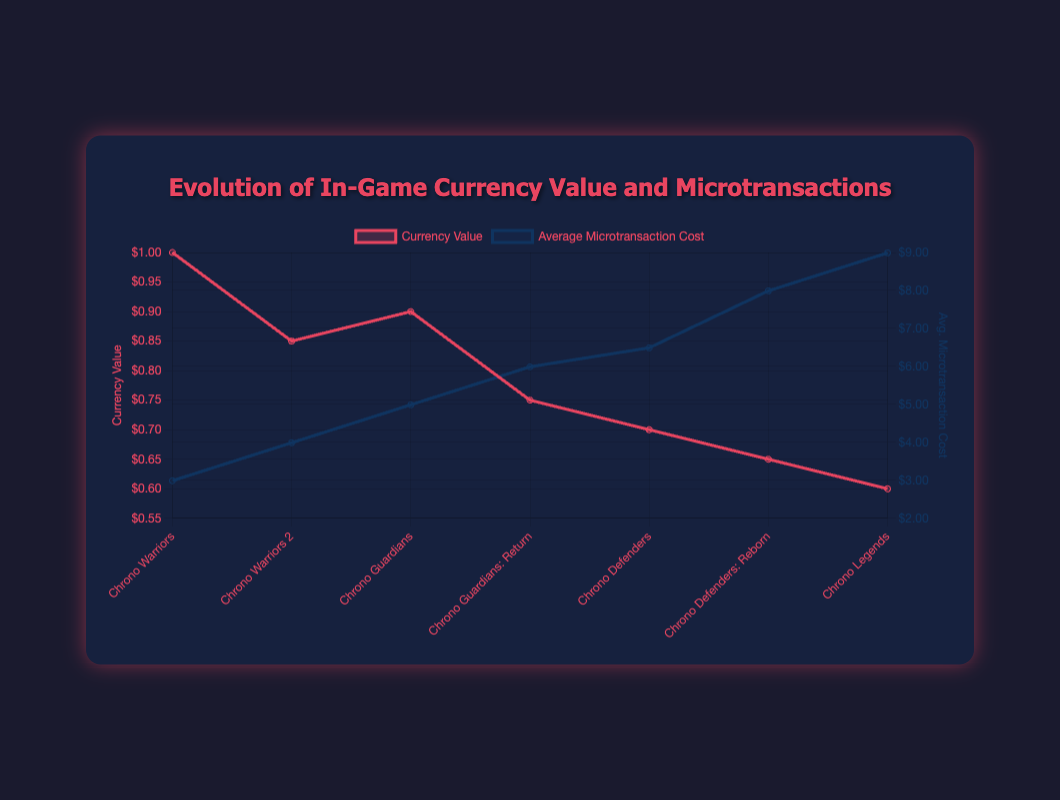What is the trend of the currency value from "Chrono Warriors" to "Chrono Legends"? The currency value decreases consistently from $1.00 in "Chrono Warriors" to $0.60 in "Chrono Legends". Each subsequent game has a lower currency value than its predecessor, indicating a downward trend.
Answer: The currency value decreases Which game has the highest average microtransaction cost? By examining the line representing average microtransaction costs, "Chrono Legends" has the highest value at $8.99. The corresponding peak at this point visually confirms this.
Answer: Chrono Legends How much has the average microtransaction cost increased from "Chrono Warriors" to "Chrono Legends"? The average microtransaction cost in "Chrono Warriors" is $2.99, while in "Chrono Legends" it is $8.99. The increase is $8.99 - $2.99 = $6.00.
Answer: $6.00 In which year did the currency value first drop below $0.80? The currency value dropped below $0.80 for the first time in 2016 with "Chrono Guardians: Return", where the value was $0.75.
Answer: 2016 Which game has a higher currency value, "Chrono Warriors 2" or "Chrono Guardians"? Comparing the currency values of "Chrono Warriors 2" ($0.85) and "Chrono Guardians" ($0.90) shows that "Chrono Guardians" has a higher currency value.
Answer: Chrono Guardians What is the total average microtransaction cost for all the games combined? The total is found by summing up the average microtransaction costs for each game: $2.99 + $3.99 + $4.99 + $5.99 + $6.49 + $7.99 + $8.99 = $41.43.
Answer: $41.43 What is the difference in currency value between "Chrono Guardians" and "Chrono Defenders: Reborn"? The currency value for "Chrono Guardians" is $0.90, while for "Chrono Defenders: Reborn" it is $0.65. The difference is $0.90 - $0.65 = $0.25.
Answer: $0.25 How does the change in currency value compare to the change in average microtransaction cost over time? Generally, the currency value decreases over time, while the average microtransaction cost increases. This is visually confirmed by the downward trend in the currency value line and the upward trend in the average microtransaction cost line across the game titles.
Answer: Opposite trends Which game has the steepest drop in currency value compared to its predecessor? The steepest drop occurs between "Chrono Guardians" ($0.90) and "Chrono Guardians: Return" ($0.75). The difference is $0.90 - $0.75 = $0.15.
Answer: Chrono Guardians: Return 